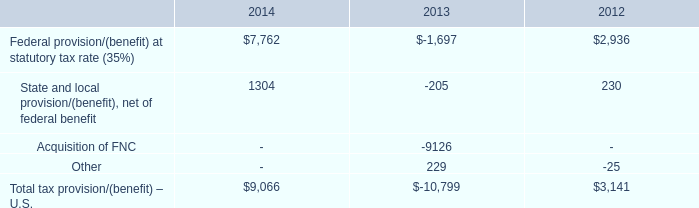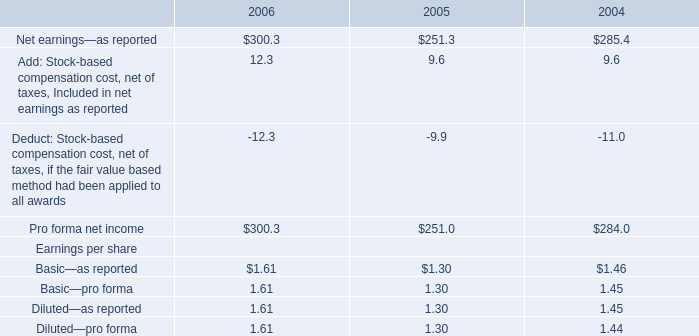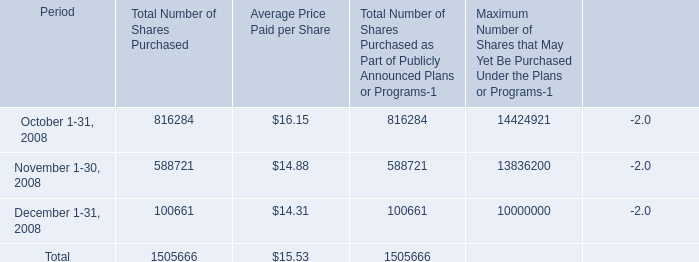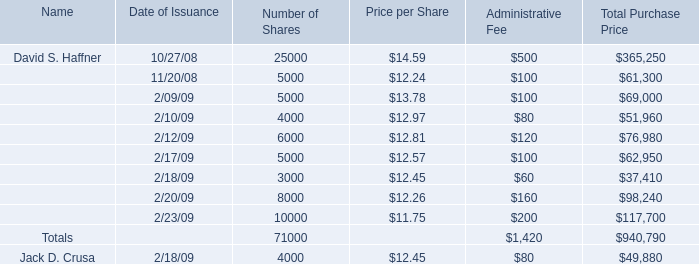What's the total value of all Price per Share that are in the range of 13 and 15 for Price per Share? 
Computations: (14.59 + 13.78)
Answer: 28.37. 